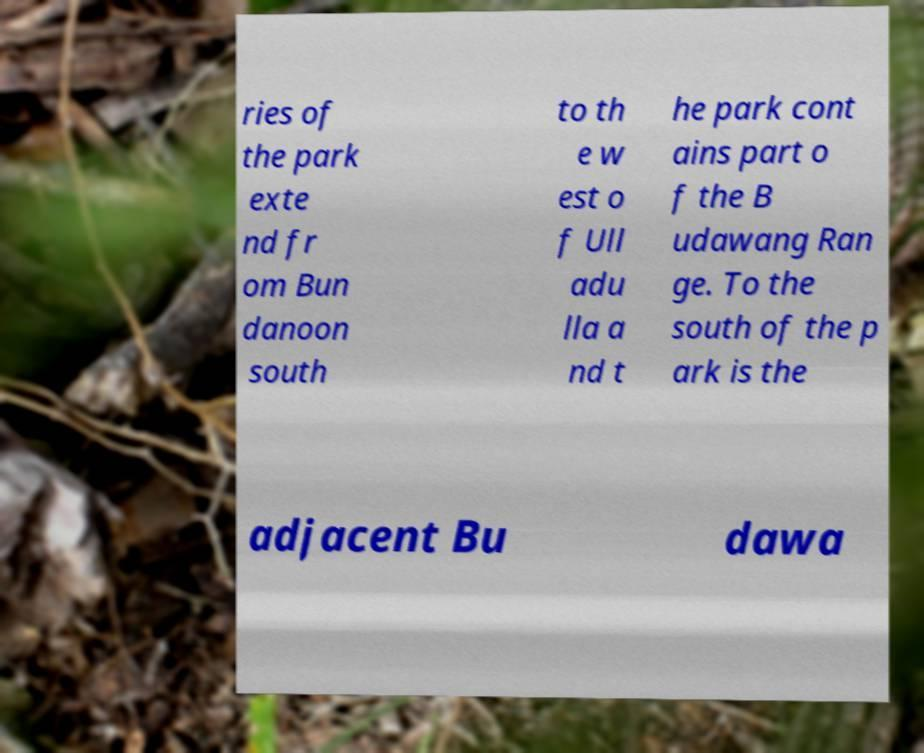What messages or text are displayed in this image? I need them in a readable, typed format. ries of the park exte nd fr om Bun danoon south to th e w est o f Ull adu lla a nd t he park cont ains part o f the B udawang Ran ge. To the south of the p ark is the adjacent Bu dawa 